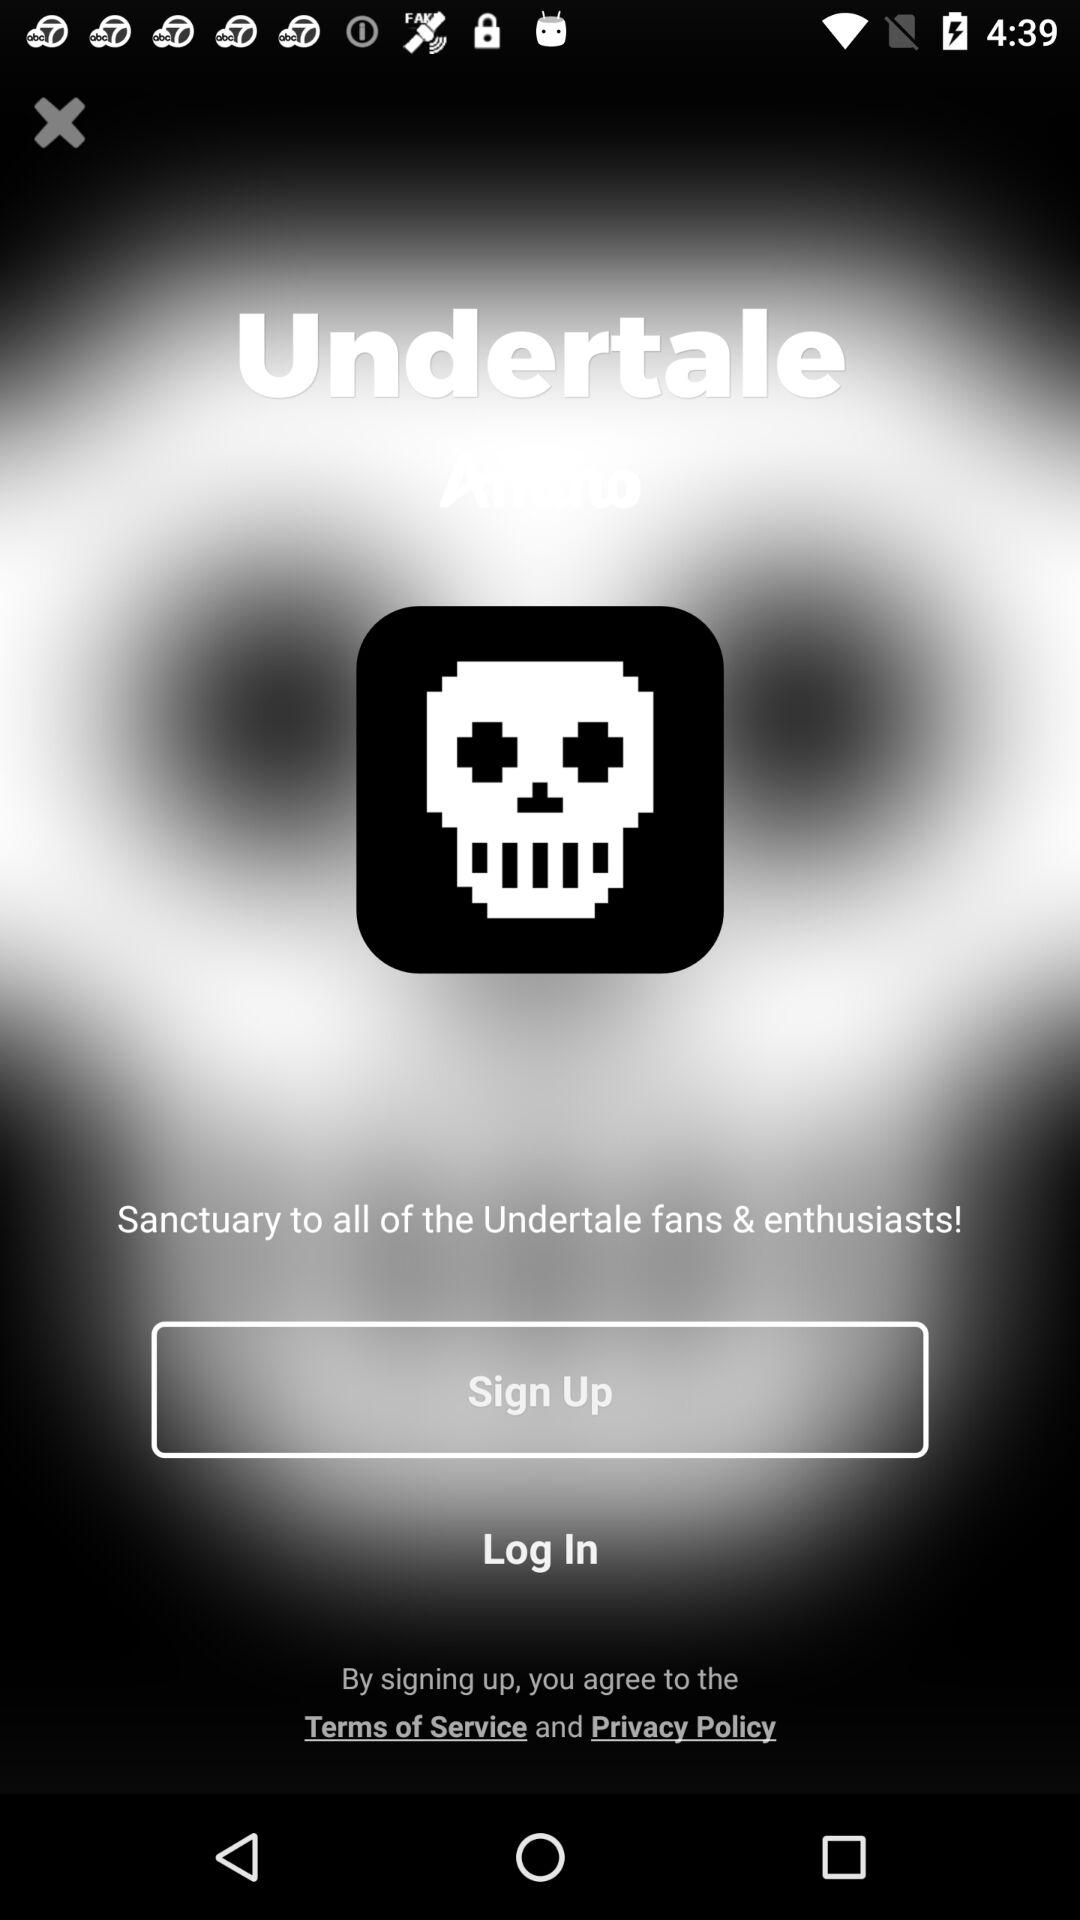What is the app name? The app name is "Undertale". 